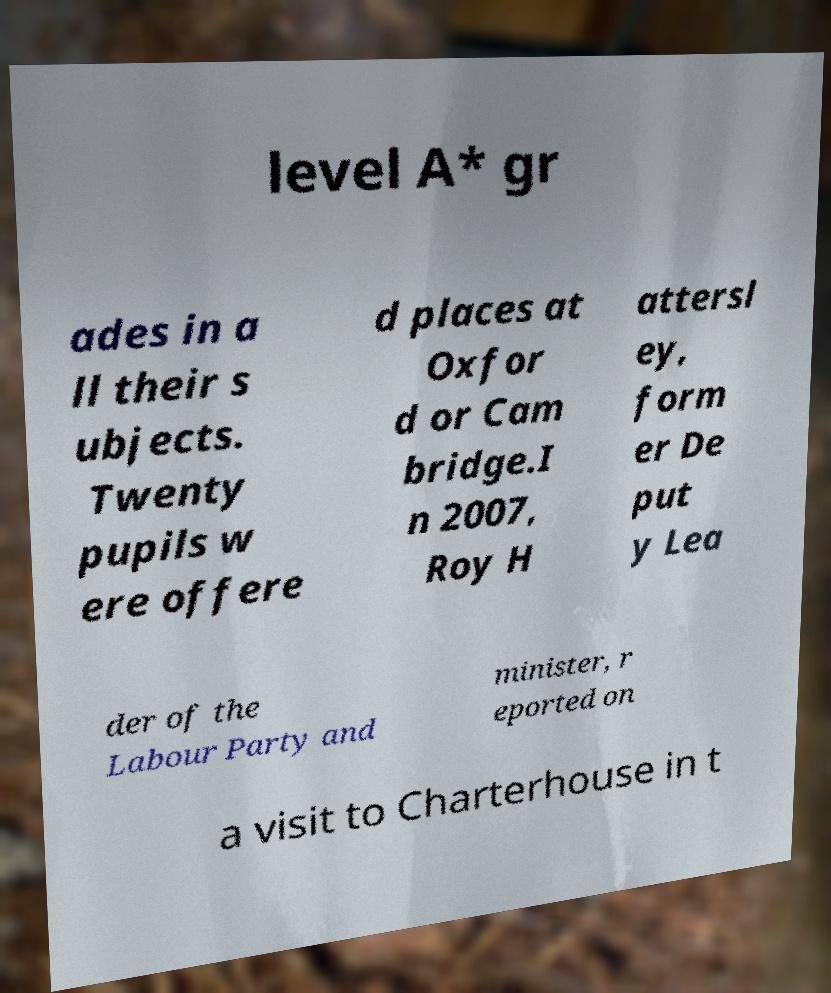Can you read and provide the text displayed in the image?This photo seems to have some interesting text. Can you extract and type it out for me? level A* gr ades in a ll their s ubjects. Twenty pupils w ere offere d places at Oxfor d or Cam bridge.I n 2007, Roy H attersl ey, form er De put y Lea der of the Labour Party and minister, r eported on a visit to Charterhouse in t 